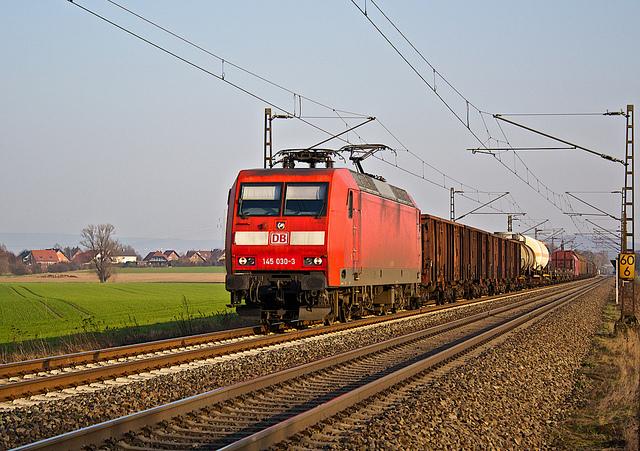What powers this engine?
Keep it brief. Electricity. What are the structures in the horizon in the background?
Short answer required. Houses. What kind of vehicle is this?
Keep it brief. Train. 